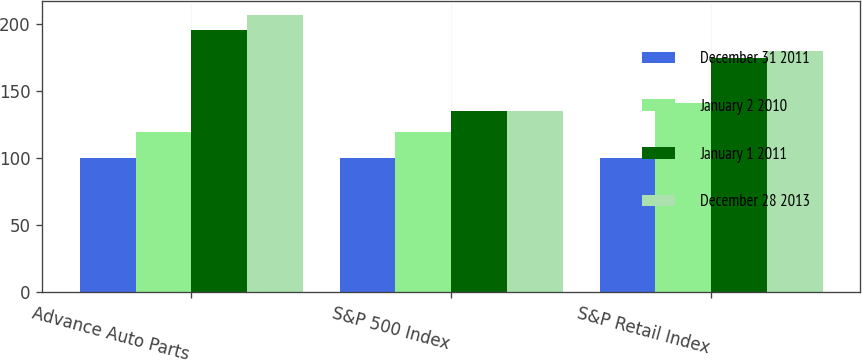<chart> <loc_0><loc_0><loc_500><loc_500><stacked_bar_chart><ecel><fcel>Advance Auto Parts<fcel>S&P 500 Index<fcel>S&P Retail Index<nl><fcel>December 31 2011<fcel>100<fcel>100<fcel>100<nl><fcel>January 2 2010<fcel>119.28<fcel>119.67<fcel>141.28<nl><fcel>January 1 2011<fcel>195.8<fcel>134.97<fcel>174.7<nl><fcel>December 28 2013<fcel>206.86<fcel>134.96<fcel>179.79<nl></chart> 